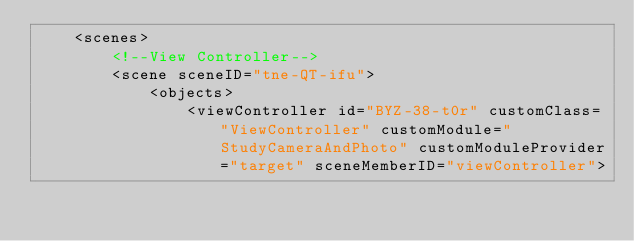<code> <loc_0><loc_0><loc_500><loc_500><_XML_>    <scenes>
        <!--View Controller-->
        <scene sceneID="tne-QT-ifu">
            <objects>
                <viewController id="BYZ-38-t0r" customClass="ViewController" customModule="StudyCameraAndPhoto" customModuleProvider="target" sceneMemberID="viewController"></code> 